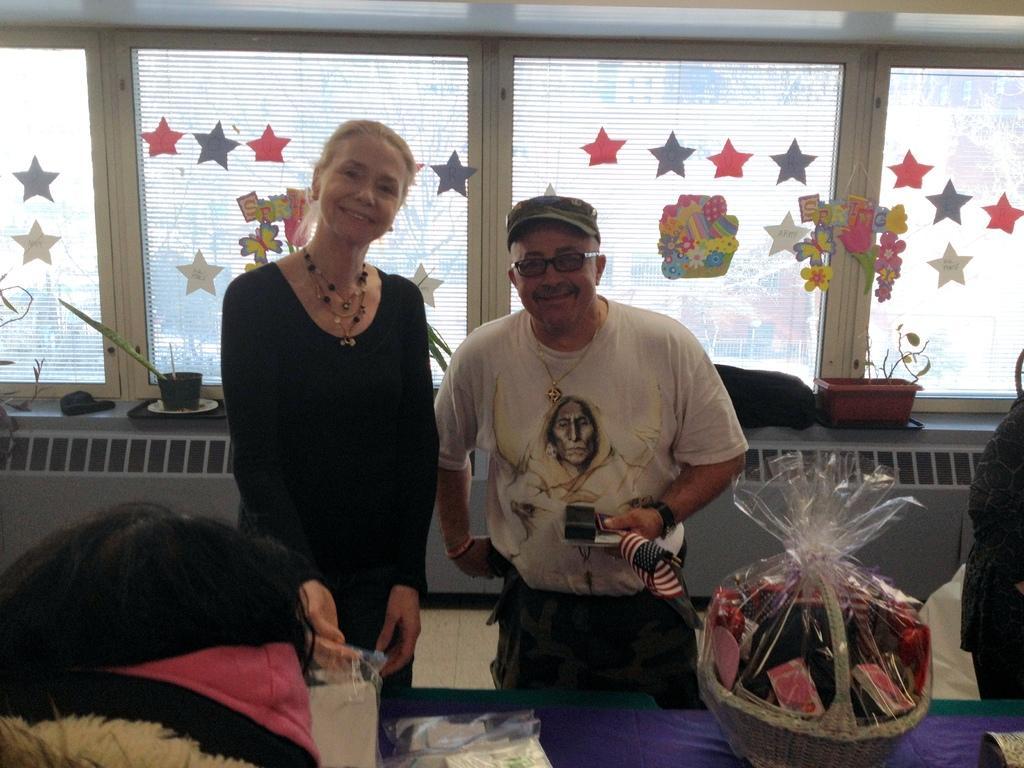Describe this image in one or two sentences. In front of the image we can see the head of a person. There is a table. On top of it there are some objects. Behind the table there are people standing. In the background of the image there are flower pots and there are some other objects on the platform. There are stickers on the glass windows. 